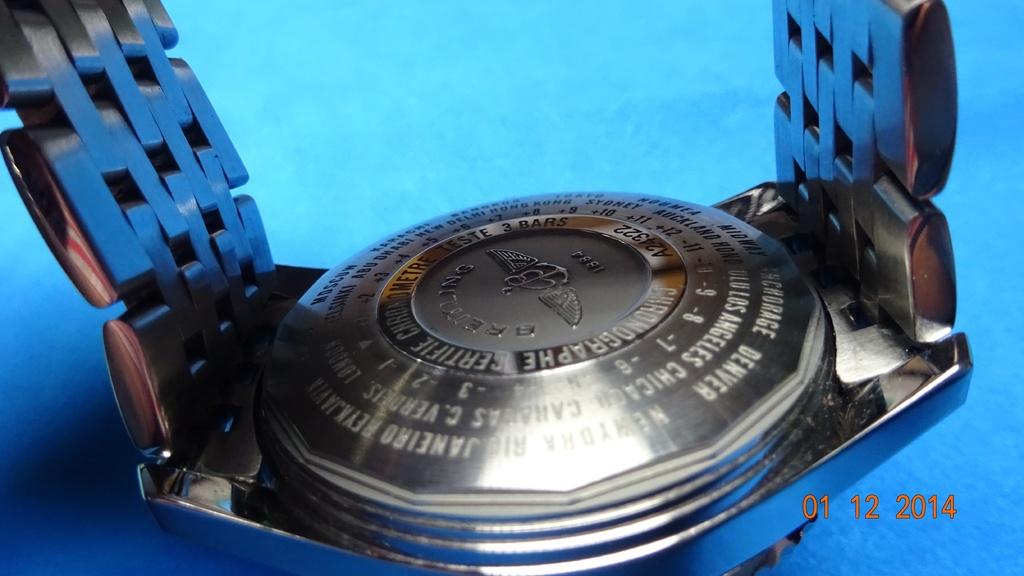What is the date in the bottom right/?
Provide a succinct answer. 01 12 2014. 